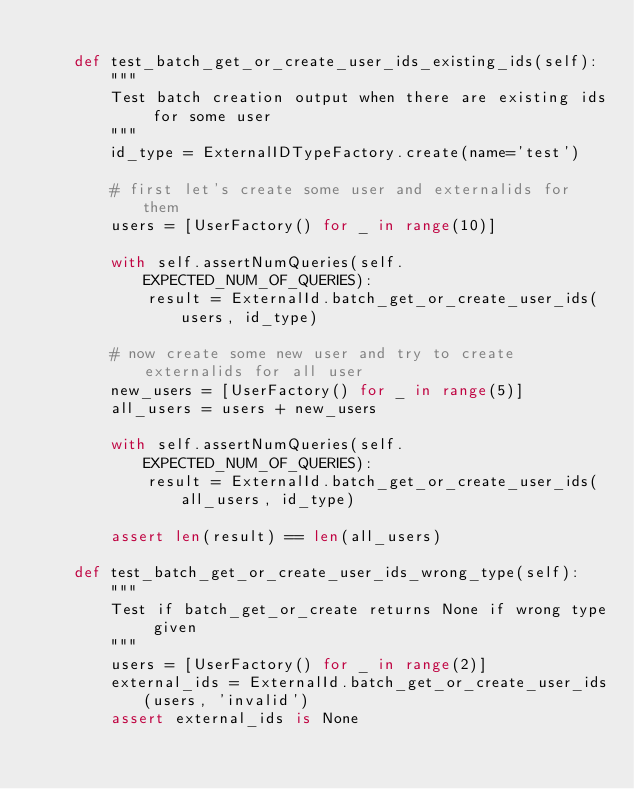Convert code to text. <code><loc_0><loc_0><loc_500><loc_500><_Python_>
    def test_batch_get_or_create_user_ids_existing_ids(self):
        """
        Test batch creation output when there are existing ids for some user
        """
        id_type = ExternalIDTypeFactory.create(name='test')

        # first let's create some user and externalids for them
        users = [UserFactory() for _ in range(10)]

        with self.assertNumQueries(self.EXPECTED_NUM_OF_QUERIES):
            result = ExternalId.batch_get_or_create_user_ids(users, id_type)

        # now create some new user and try to create externalids for all user
        new_users = [UserFactory() for _ in range(5)]
        all_users = users + new_users

        with self.assertNumQueries(self.EXPECTED_NUM_OF_QUERIES):
            result = ExternalId.batch_get_or_create_user_ids(all_users, id_type)

        assert len(result) == len(all_users)

    def test_batch_get_or_create_user_ids_wrong_type(self):
        """
        Test if batch_get_or_create returns None if wrong type given
        """
        users = [UserFactory() for _ in range(2)]
        external_ids = ExternalId.batch_get_or_create_user_ids(users, 'invalid')
        assert external_ids is None
</code> 